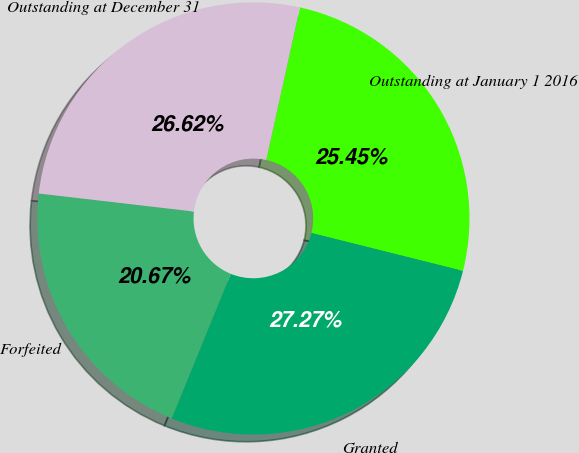Convert chart to OTSL. <chart><loc_0><loc_0><loc_500><loc_500><pie_chart><fcel>Outstanding at January 1 2016<fcel>Granted<fcel>Forfeited<fcel>Outstanding at December 31<nl><fcel>25.45%<fcel>27.27%<fcel>20.67%<fcel>26.62%<nl></chart> 